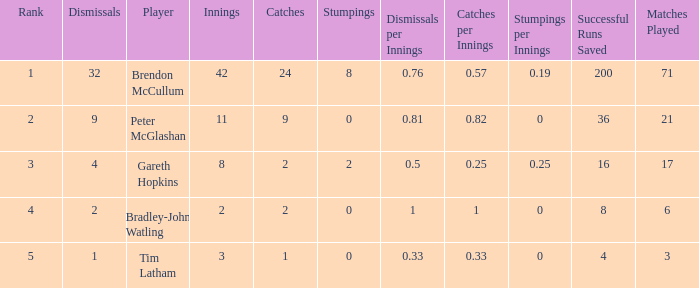Could you parse the entire table as a dict? {'header': ['Rank', 'Dismissals', 'Player', 'Innings', 'Catches', 'Stumpings', 'Dismissals per Innings', 'Catches per Innings', 'Stumpings per Innings', 'Successful Runs Saved', 'Matches Played'], 'rows': [['1', '32', 'Brendon McCullum', '42', '24', '8', '0.76', '0.57', '0.19', '200', '71'], ['2', '9', 'Peter McGlashan', '11', '9', '0', '0.81', '0.82', '0', '36', '21'], ['3', '4', 'Gareth Hopkins', '8', '2', '2', '0.5', '0.25', '0.25', '16', '17'], ['4', '2', 'Bradley-John Watling', '2', '2', '0', '1', '1', '0', '8', '6'], ['5', '1', 'Tim Latham', '3', '1', '0', '0.33', '0.33', '0', '4', '3']]} How many stumpings did the player Tim Latham have? 0.0. 